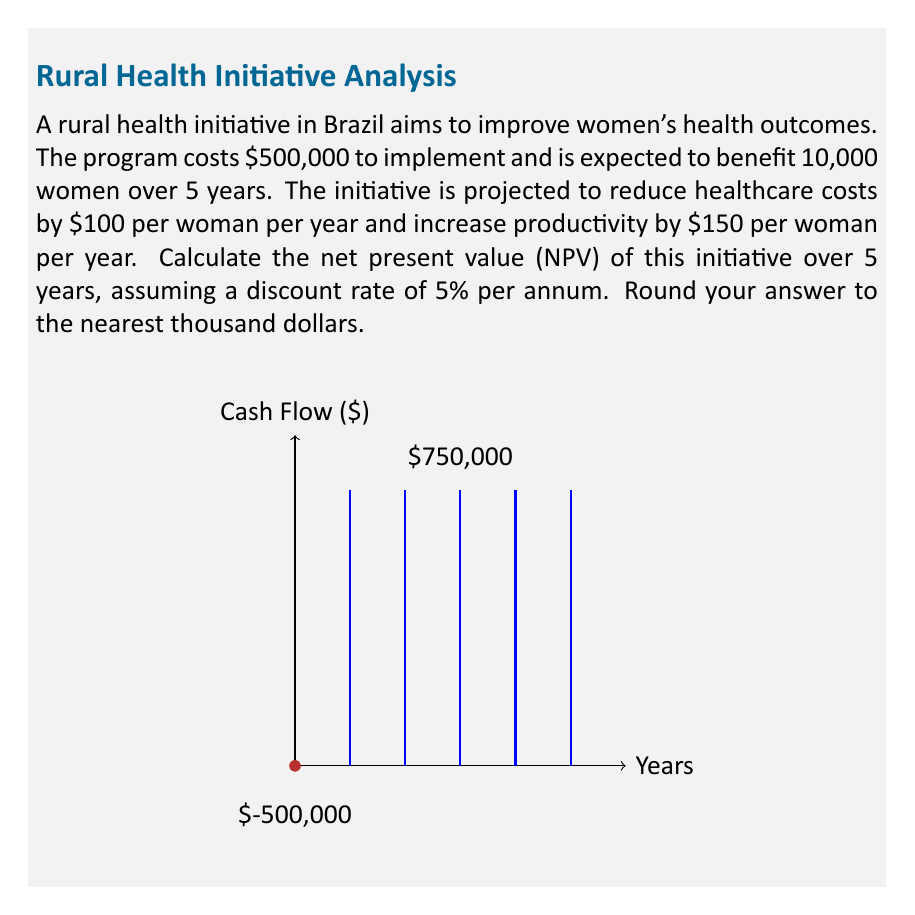Could you help me with this problem? Let's approach this step-by-step:

1) First, we need to calculate the annual benefit:
   Annual benefit per woman = $100 (healthcare cost reduction) + $150 (productivity increase) = $250
   Total annual benefit = $250 × 10,000 women = $2,500,000

2) The annual net cash flow:
   Annual net cash flow = $2,500,000 - $0 = $2,500,000 (as the cost is only incurred at the start)

3) We need to calculate the present value of these cash flows for each year. The formula for present value is:
   $PV = \frac{CF}{(1+r)^t}$
   Where CF is the cash flow, r is the discount rate, and t is the time period.

4) Let's calculate the PV for each year:
   Year 1: $PV_1 = \frac{2,500,000}{(1+0.05)^1} = 2,380,952.38$
   Year 2: $PV_2 = \frac{2,500,000}{(1+0.05)^2} = 2,267,573.70$
   Year 3: $PV_3 = \frac{2,500,000}{(1+0.05)^3} = 2,159,594.00$
   Year 4: $PV_4 = \frac{2,500,000}{(1+0.05)^4} = 2,056,756.19$
   Year 5: $PV_5 = \frac{2,500,000}{(1+0.05)^5} = 1,958,815.42$

5) Sum up all the present values:
   $\sum PV = 2,380,952.38 + 2,267,573.70 + 2,159,594.00 + 2,056,756.19 + 1,958,815.42 = 10,823,691.69$

6) Calculate NPV by subtracting the initial investment:
   $NPV = \sum PV - \text{Initial Investment}$
   $NPV = 10,823,691.69 - 500,000 = 10,323,691.69$

7) Rounding to the nearest thousand:
   $NPV \approx 10,324,000$
Answer: $10,324,000 